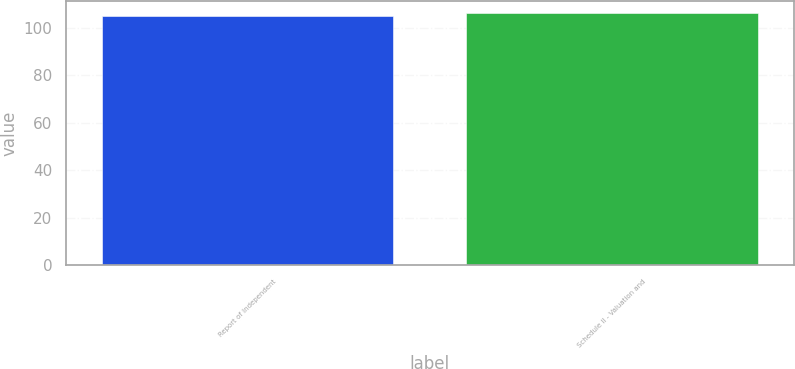Convert chart. <chart><loc_0><loc_0><loc_500><loc_500><bar_chart><fcel>Report of Independent<fcel>Schedule II - Valuation and<nl><fcel>105<fcel>106<nl></chart> 